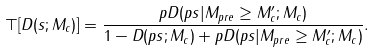<formula> <loc_0><loc_0><loc_500><loc_500>\top [ D ( s ; M _ { c } ) ] = \frac { p D ( p s | M _ { p r e } \geq M _ { c } ^ { \prime } ; M _ { c } ) } { 1 - D ( p s ; M _ { c } ) + p D ( p s | M _ { p r e } \geq M _ { c } ^ { \prime } ; M _ { c } ) } .</formula> 